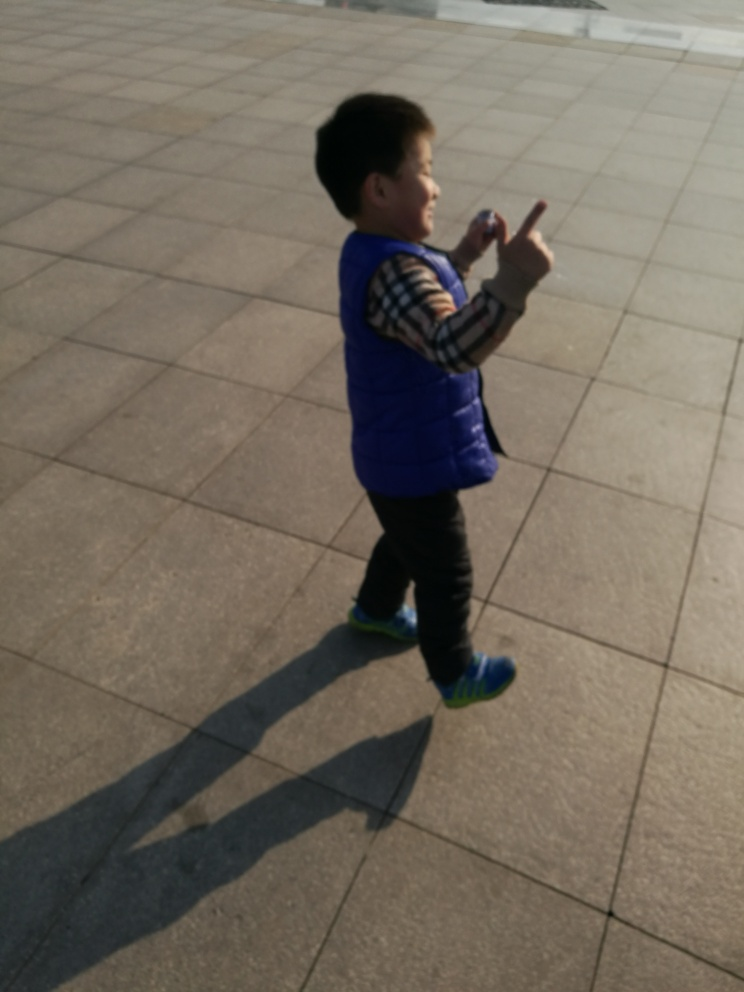What could the child be looking at or pointing to? The child appears to be pointing at something out of frame with an enthusiastic expression. It's possible the child is interacting with a person they know, drawing attention to an interesting object, or simply playing and imagining. 